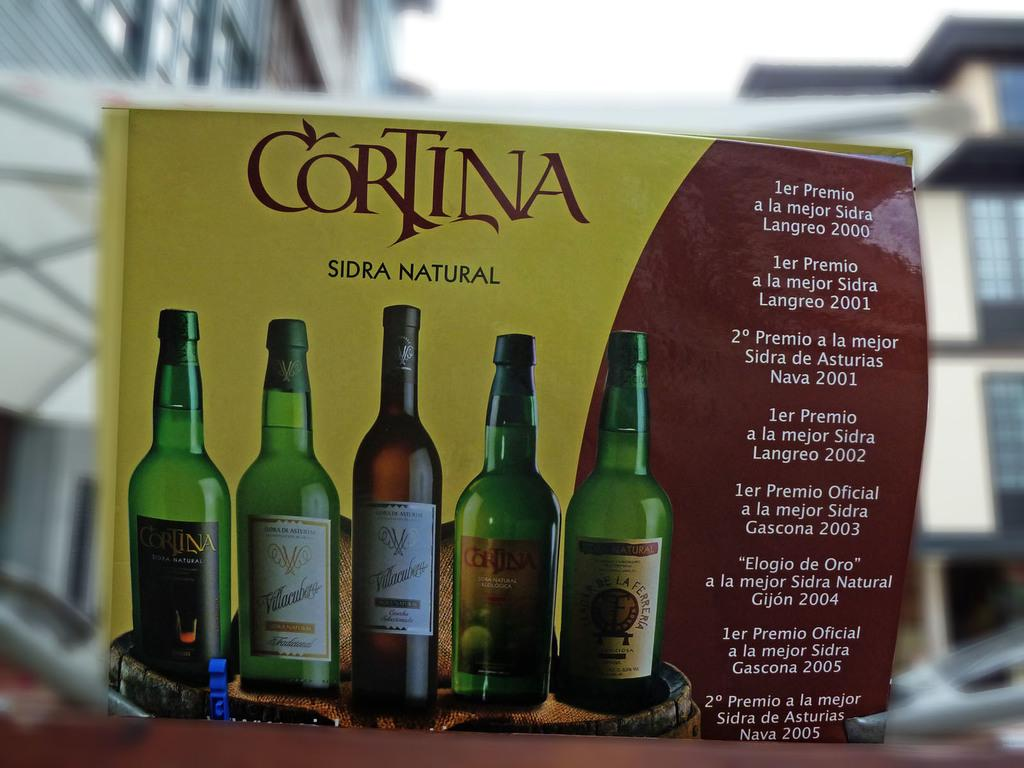Provide a one-sentence caption for the provided image. The Cortina cider has won many awards from 2000 to 2005. 